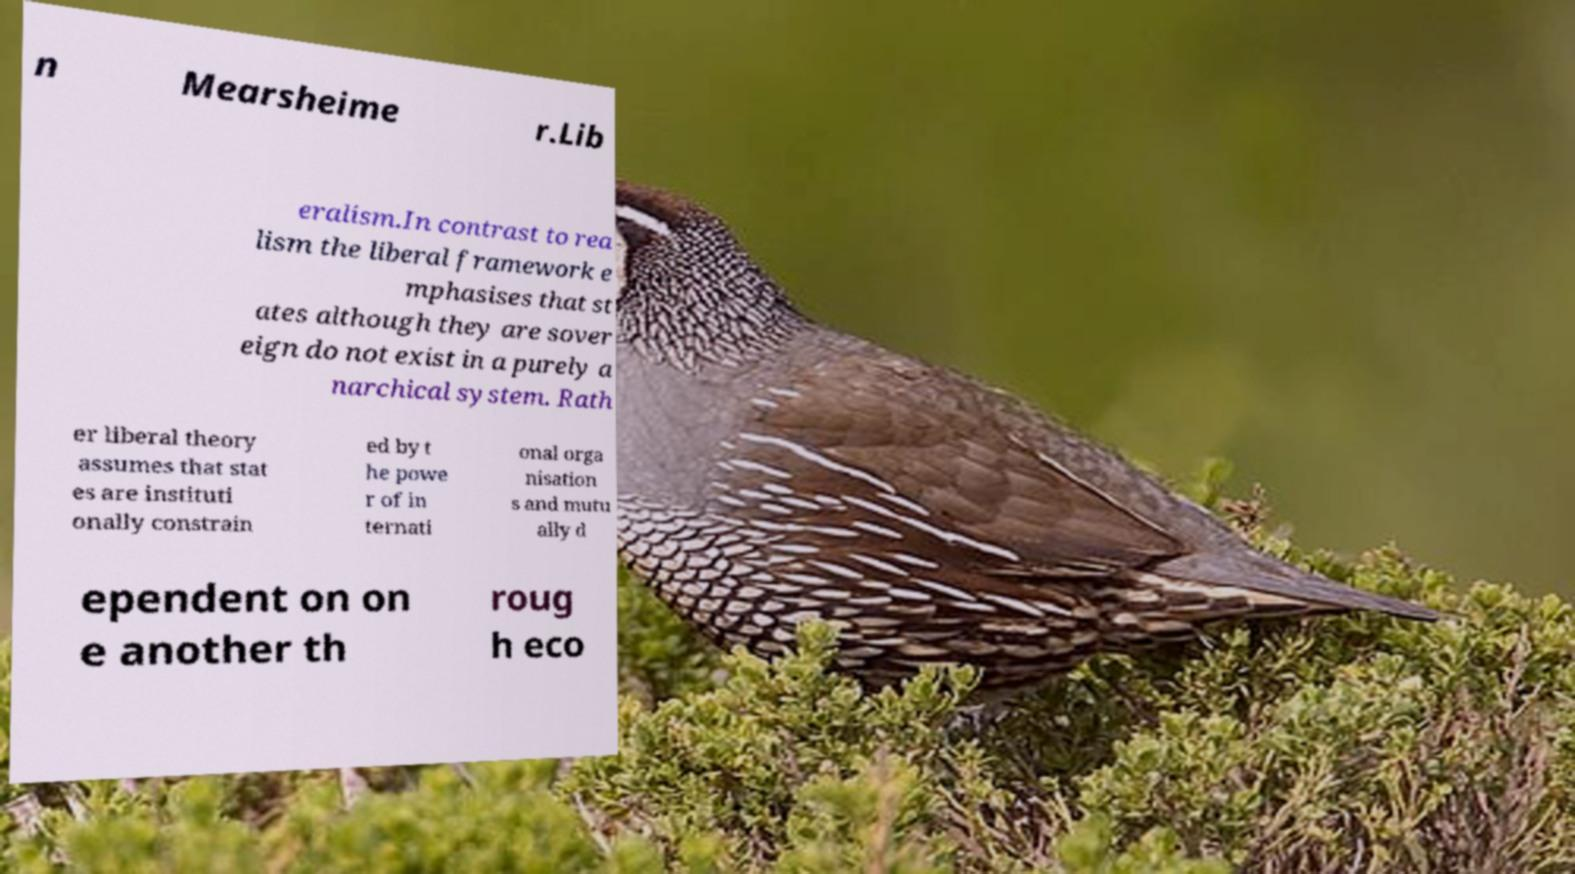Can you read and provide the text displayed in the image?This photo seems to have some interesting text. Can you extract and type it out for me? n Mearsheime r.Lib eralism.In contrast to rea lism the liberal framework e mphasises that st ates although they are sover eign do not exist in a purely a narchical system. Rath er liberal theory assumes that stat es are instituti onally constrain ed by t he powe r of in ternati onal orga nisation s and mutu ally d ependent on on e another th roug h eco 